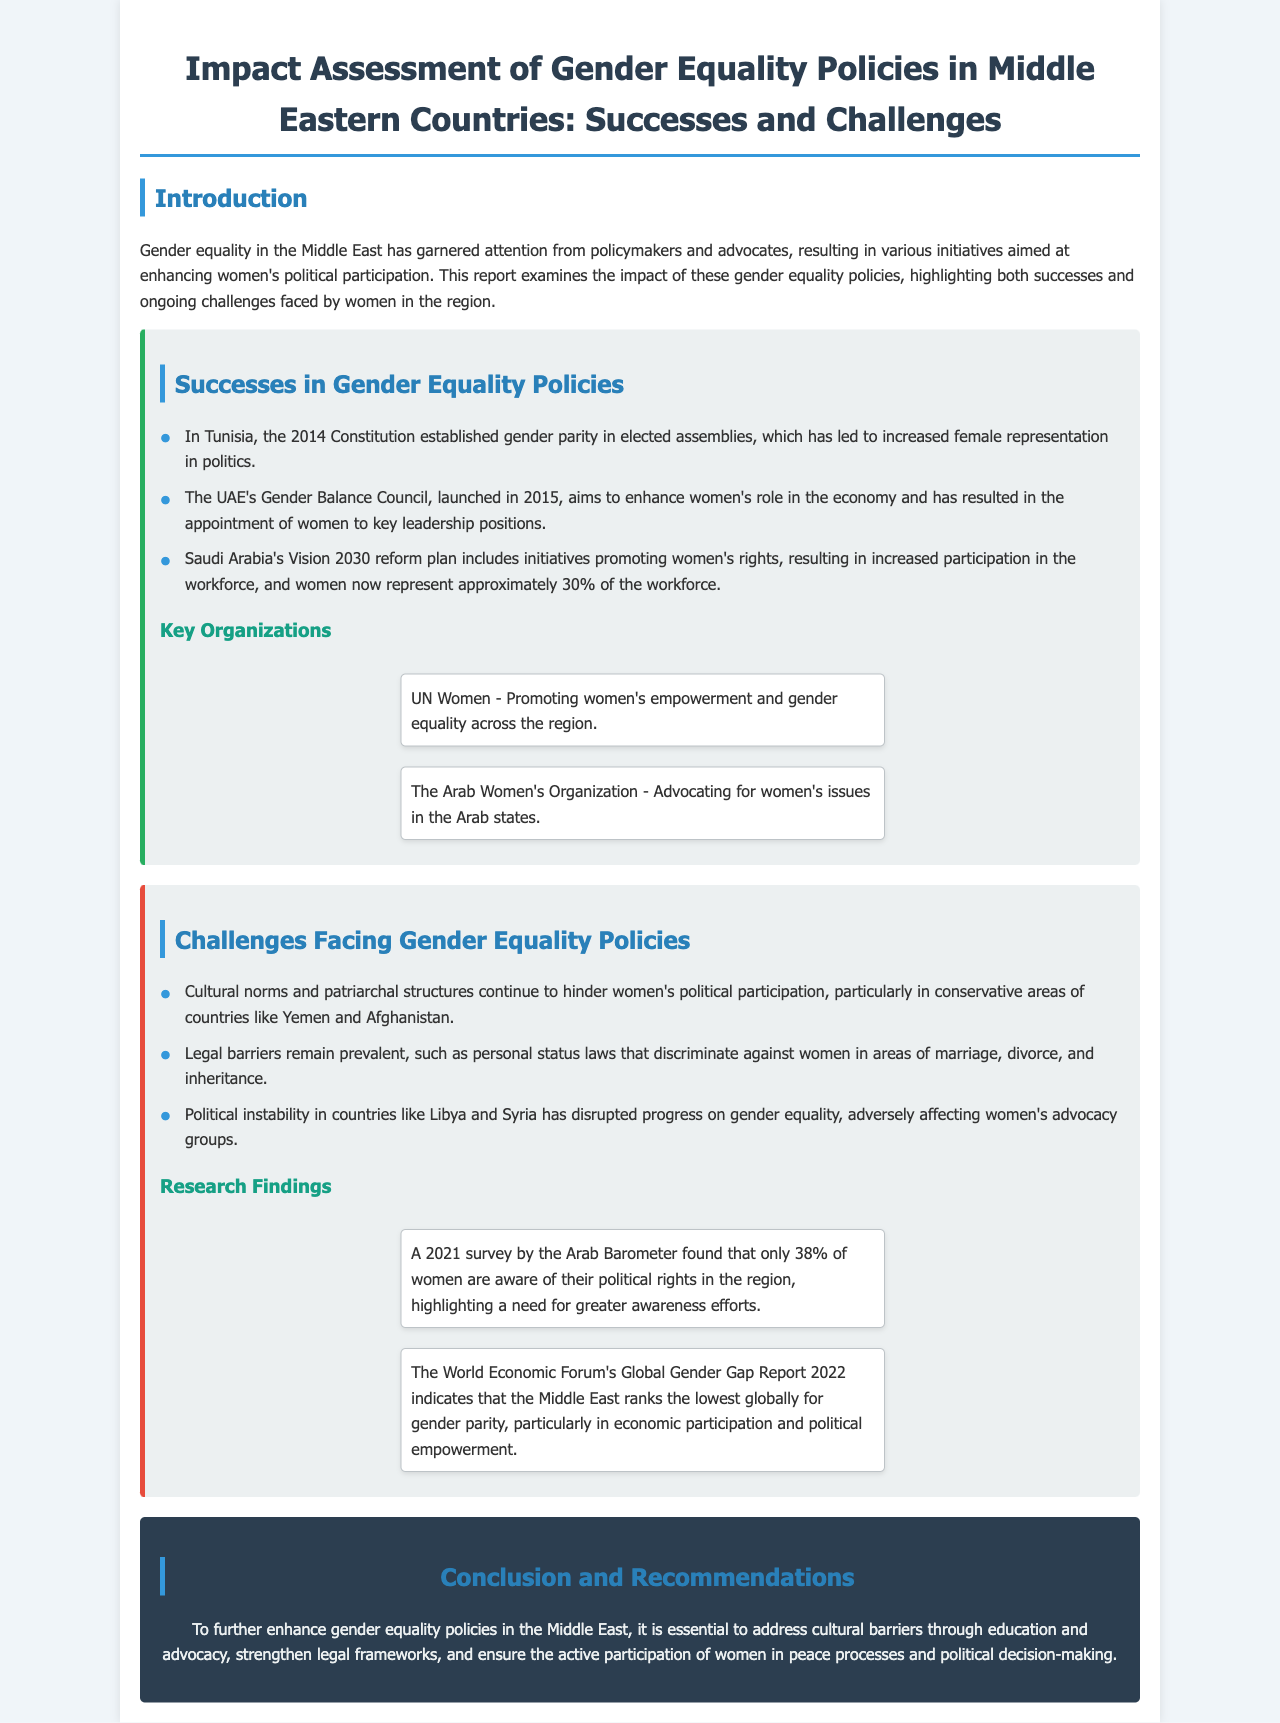What is the title of the report? The title of the report summarizes the overall focus on gender equality policies and their assessment in Middle Eastern countries.
Answer: Impact Assessment of Gender Equality Policies in Middle Eastern Countries: Successes and Challenges What percentage of Saudi Arabia's workforce consists of women? The report mentions that this demographic detail reflects the impact of the Vision 2030 reform plan on women's participation in the workforce.
Answer: Approximately 30% Which organization promotes women's empowerment across the Middle East? This organization is specifically mentioned in the document as a key player in advocating for gender equality and women's rights.
Answer: UN Women What cultural factor hinders women's political participation in Yemen and Afghanistan? This question refers to the challenges outlined in the report regarding societal structures affecting women's roles in these specific countries.
Answer: Cultural norms What year was the UAE's Gender Balance Council launched? This date is important in understanding when efforts to enhance women's roles in the economy began in the UAE.
Answer: 2015 What was the awareness percentage of women's political rights according to the Arab Barometer survey in 2021? The report includes this statistic to highlight the need for greater awareness and education among women regarding their rights.
Answer: 38% What legal barriers remain prevalent affecting women according to the report? The challenges section discusses specific legal issues that continue to discriminate against women in various aspects of life.
Answer: Personal status laws Which country ranks lowest globally for gender parity in political empowerment according to the Global Gender Gap Report? This finding emphasizes the region's challenges in achieving gender equality, as reported by a significant global organization.
Answer: Middle East 